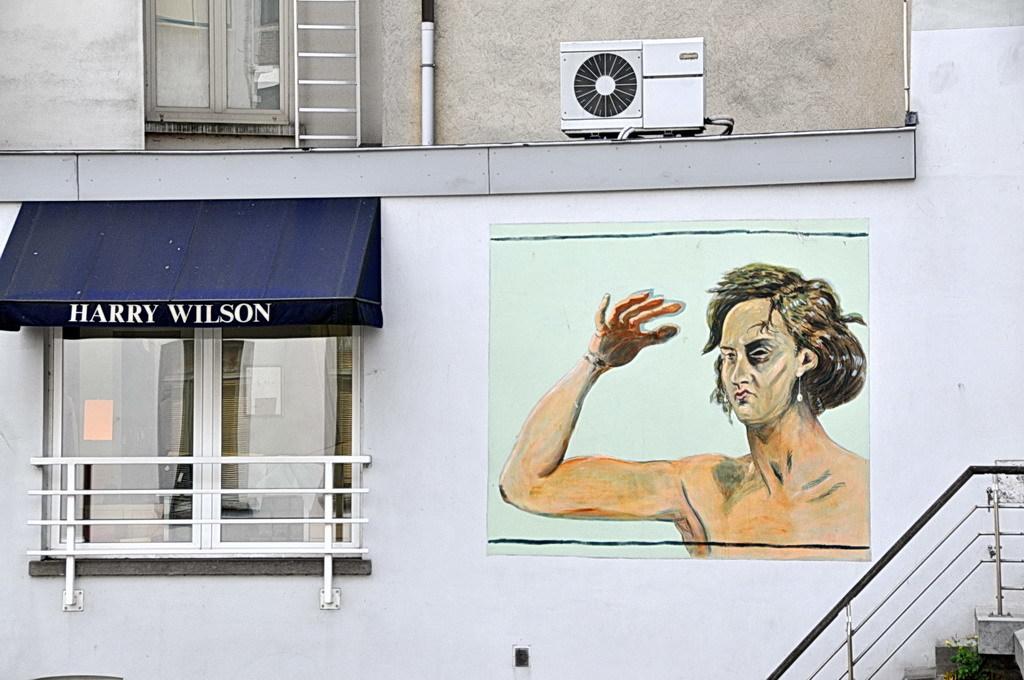Whose name is over the window?
Your answer should be compact. Harry wilson. 